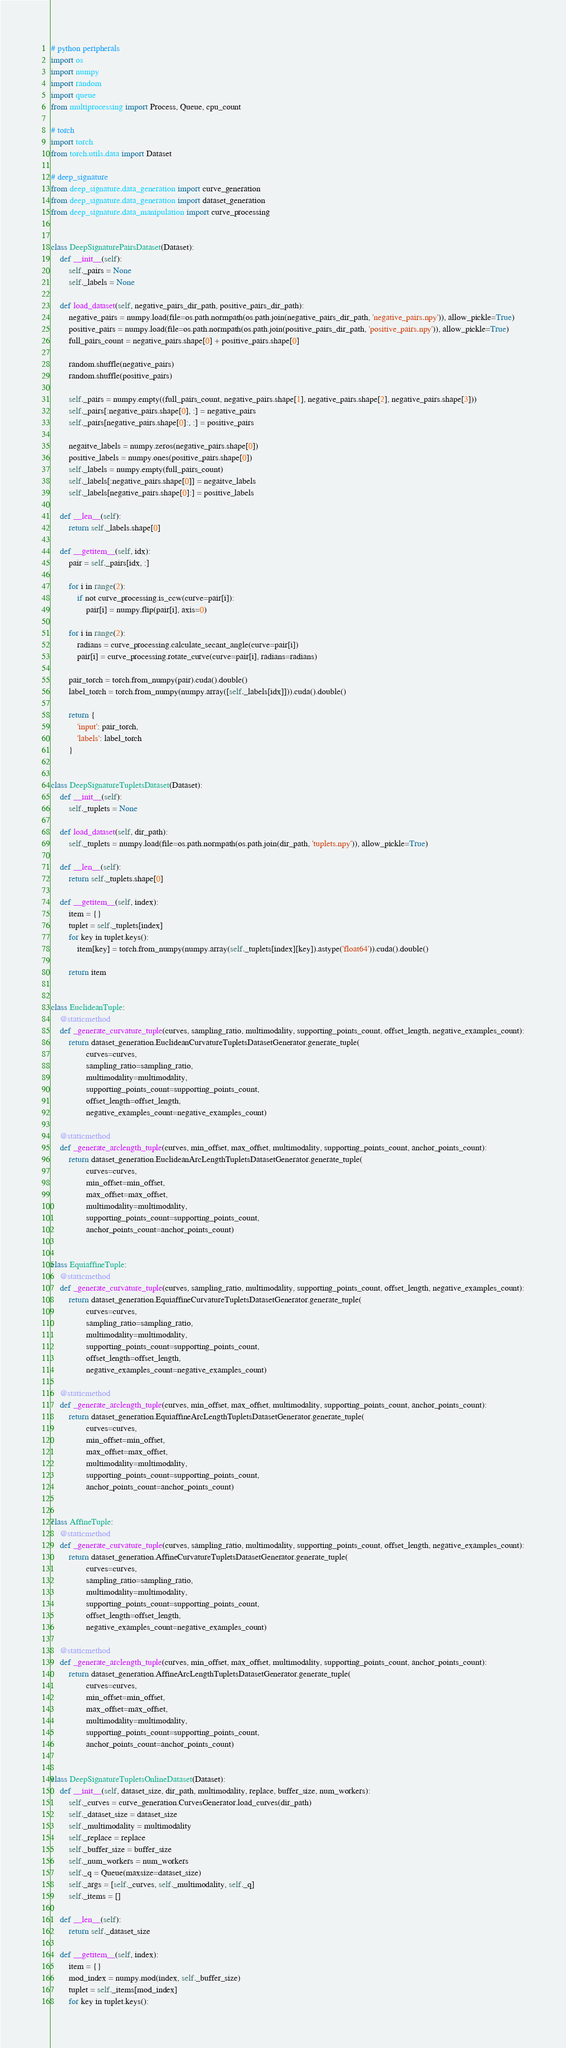<code> <loc_0><loc_0><loc_500><loc_500><_Python_># python peripherals
import os
import numpy
import random
import queue
from multiprocessing import Process, Queue, cpu_count

# torch
import torch
from torch.utils.data import Dataset

# deep_signature
from deep_signature.data_generation import curve_generation
from deep_signature.data_generation import dataset_generation
from deep_signature.data_manipulation import curve_processing


class DeepSignaturePairsDataset(Dataset):
    def __init__(self):
        self._pairs = None
        self._labels = None

    def load_dataset(self, negative_pairs_dir_path, positive_pairs_dir_path):
        negative_pairs = numpy.load(file=os.path.normpath(os.path.join(negative_pairs_dir_path, 'negative_pairs.npy')), allow_pickle=True)
        positive_pairs = numpy.load(file=os.path.normpath(os.path.join(positive_pairs_dir_path, 'positive_pairs.npy')), allow_pickle=True)
        full_pairs_count = negative_pairs.shape[0] + positive_pairs.shape[0]

        random.shuffle(negative_pairs)
        random.shuffle(positive_pairs)

        self._pairs = numpy.empty((full_pairs_count, negative_pairs.shape[1], negative_pairs.shape[2], negative_pairs.shape[3]))
        self._pairs[:negative_pairs.shape[0], :] = negative_pairs
        self._pairs[negative_pairs.shape[0]:, :] = positive_pairs

        negaitve_labels = numpy.zeros(negative_pairs.shape[0])
        positive_labels = numpy.ones(positive_pairs.shape[0])
        self._labels = numpy.empty(full_pairs_count)
        self._labels[:negative_pairs.shape[0]] = negaitve_labels
        self._labels[negative_pairs.shape[0]:] = positive_labels

    def __len__(self):
        return self._labels.shape[0]

    def __getitem__(self, idx):
        pair = self._pairs[idx, :]

        for i in range(2):
            if not curve_processing.is_ccw(curve=pair[i]):
                pair[i] = numpy.flip(pair[i], axis=0)

        for i in range(2):
            radians = curve_processing.calculate_secant_angle(curve=pair[i])
            pair[i] = curve_processing.rotate_curve(curve=pair[i], radians=radians)

        pair_torch = torch.from_numpy(pair).cuda().double()
        label_torch = torch.from_numpy(numpy.array([self._labels[idx]])).cuda().double()

        return {
            'input': pair_torch,
            'labels': label_torch
        }


class DeepSignatureTupletsDataset(Dataset):
    def __init__(self):
        self._tuplets = None

    def load_dataset(self, dir_path):
        self._tuplets = numpy.load(file=os.path.normpath(os.path.join(dir_path, 'tuplets.npy')), allow_pickle=True)

    def __len__(self):
        return self._tuplets.shape[0]

    def __getitem__(self, index):
        item = {}
        tuplet = self._tuplets[index]
        for key in tuplet.keys():
            item[key] = torch.from_numpy(numpy.array(self._tuplets[index][key]).astype('float64')).cuda().double()

        return item


class EuclideanTuple:
    @staticmethod
    def _generate_curvature_tuple(curves, sampling_ratio, multimodality, supporting_points_count, offset_length, negative_examples_count):
        return dataset_generation.EuclideanCurvatureTupletsDatasetGenerator.generate_tuple(
                curves=curves,
                sampling_ratio=sampling_ratio,
                multimodality=multimodality,
                supporting_points_count=supporting_points_count,
                offset_length=offset_length,
                negative_examples_count=negative_examples_count)

    @staticmethod
    def _generate_arclength_tuple(curves, min_offset, max_offset, multimodality, supporting_points_count, anchor_points_count):
        return dataset_generation.EuclideanArcLengthTupletsDatasetGenerator.generate_tuple(
                curves=curves,
                min_offset=min_offset,
                max_offset=max_offset,
                multimodality=multimodality,
                supporting_points_count=supporting_points_count,
                anchor_points_count=anchor_points_count)


class EquiaffineTuple:
    @staticmethod
    def _generate_curvature_tuple(curves, sampling_ratio, multimodality, supporting_points_count, offset_length, negative_examples_count):
        return dataset_generation.EquiaffineCurvatureTupletsDatasetGenerator.generate_tuple(
                curves=curves,
                sampling_ratio=sampling_ratio,
                multimodality=multimodality,
                supporting_points_count=supporting_points_count,
                offset_length=offset_length,
                negative_examples_count=negative_examples_count)

    @staticmethod
    def _generate_arclength_tuple(curves, min_offset, max_offset, multimodality, supporting_points_count, anchor_points_count):
        return dataset_generation.EquiaffineArcLengthTupletsDatasetGenerator.generate_tuple(
                curves=curves,
                min_offset=min_offset,
                max_offset=max_offset,
                multimodality=multimodality,
                supporting_points_count=supporting_points_count,
                anchor_points_count=anchor_points_count)


class AffineTuple:
    @staticmethod
    def _generate_curvature_tuple(curves, sampling_ratio, multimodality, supporting_points_count, offset_length, negative_examples_count):
        return dataset_generation.AffineCurvatureTupletsDatasetGenerator.generate_tuple(
                curves=curves,
                sampling_ratio=sampling_ratio,
                multimodality=multimodality,
                supporting_points_count=supporting_points_count,
                offset_length=offset_length,
                negative_examples_count=negative_examples_count)

    @staticmethod
    def _generate_arclength_tuple(curves, min_offset, max_offset, multimodality, supporting_points_count, anchor_points_count):
        return dataset_generation.AffineArcLengthTupletsDatasetGenerator.generate_tuple(
                curves=curves,
                min_offset=min_offset,
                max_offset=max_offset,
                multimodality=multimodality,
                supporting_points_count=supporting_points_count,
                anchor_points_count=anchor_points_count)


class DeepSignatureTupletsOnlineDataset(Dataset):
    def __init__(self, dataset_size, dir_path, multimodality, replace, buffer_size, num_workers):
        self._curves = curve_generation.CurvesGenerator.load_curves(dir_path)
        self._dataset_size = dataset_size
        self._multimodality = multimodality
        self._replace = replace
        self._buffer_size = buffer_size
        self._num_workers = num_workers
        self._q = Queue(maxsize=dataset_size)
        self._args = [self._curves, self._multimodality, self._q]
        self._items = []

    def __len__(self):
        return self._dataset_size

    def __getitem__(self, index):
        item = {}
        mod_index = numpy.mod(index, self._buffer_size)
        tuplet = self._items[mod_index]
        for key in tuplet.keys():</code> 